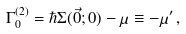Convert formula to latex. <formula><loc_0><loc_0><loc_500><loc_500>\Gamma _ { 0 } ^ { ( 2 ) } = \hbar { \Sigma } ( \vec { 0 } ; 0 ) - \mu \equiv - \mu ^ { \prime } \, ,</formula> 